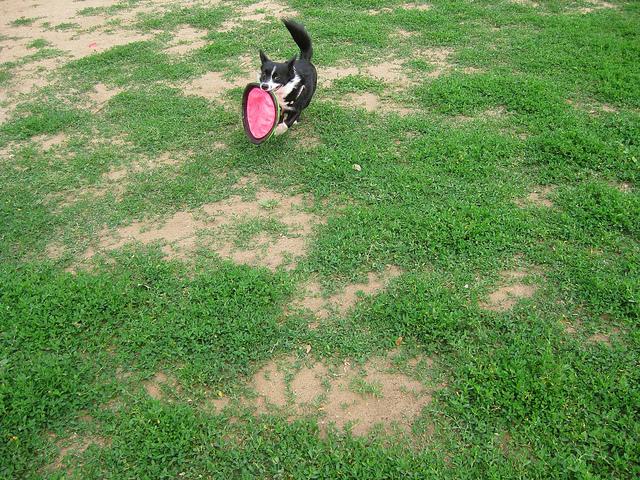Is the dog going to give the Frisbee back?
Answer briefly. Yes. Does the grass needs some maintenance?
Concise answer only. Yes. How many surfboards are there?
Short answer required. 0. What animal is this?
Short answer required. Dog. 